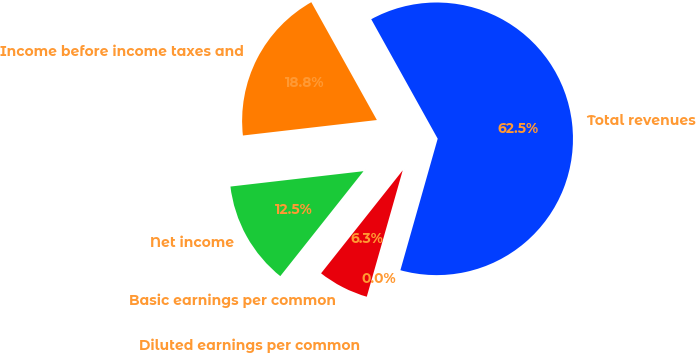Convert chart. <chart><loc_0><loc_0><loc_500><loc_500><pie_chart><fcel>Total revenues<fcel>Income before income taxes and<fcel>Net income<fcel>Basic earnings per common<fcel>Diluted earnings per common<nl><fcel>62.48%<fcel>18.75%<fcel>12.5%<fcel>6.26%<fcel>0.01%<nl></chart> 